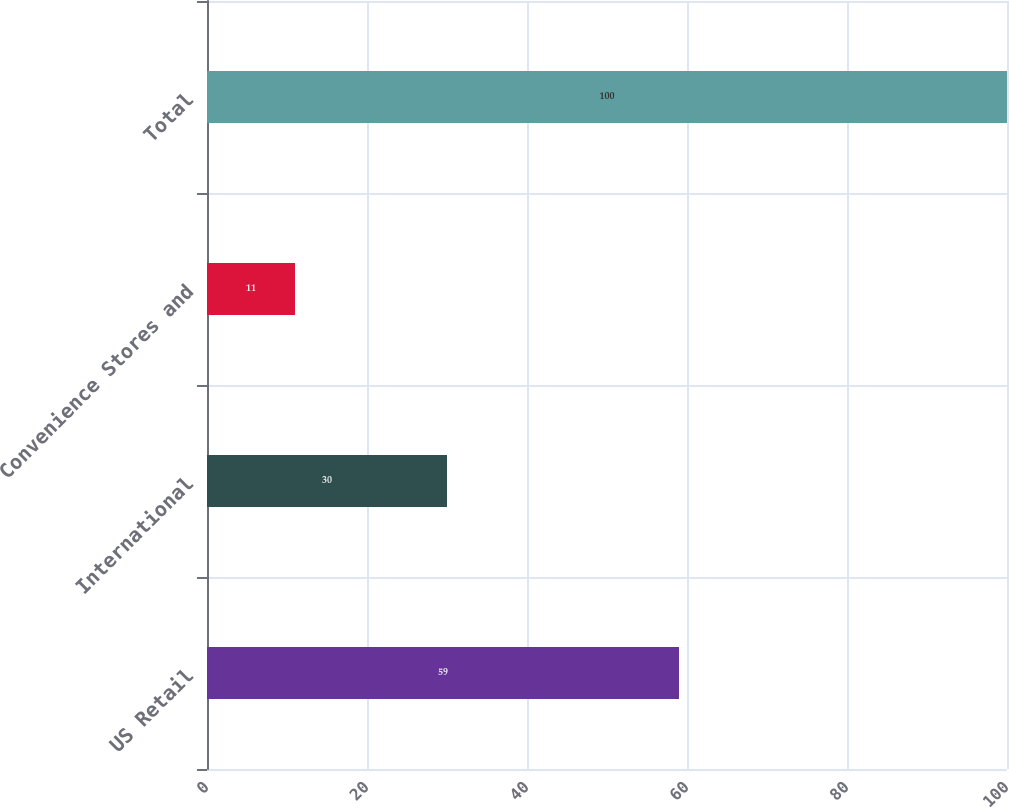Convert chart to OTSL. <chart><loc_0><loc_0><loc_500><loc_500><bar_chart><fcel>US Retail<fcel>International<fcel>Convenience Stores and<fcel>Total<nl><fcel>59<fcel>30<fcel>11<fcel>100<nl></chart> 